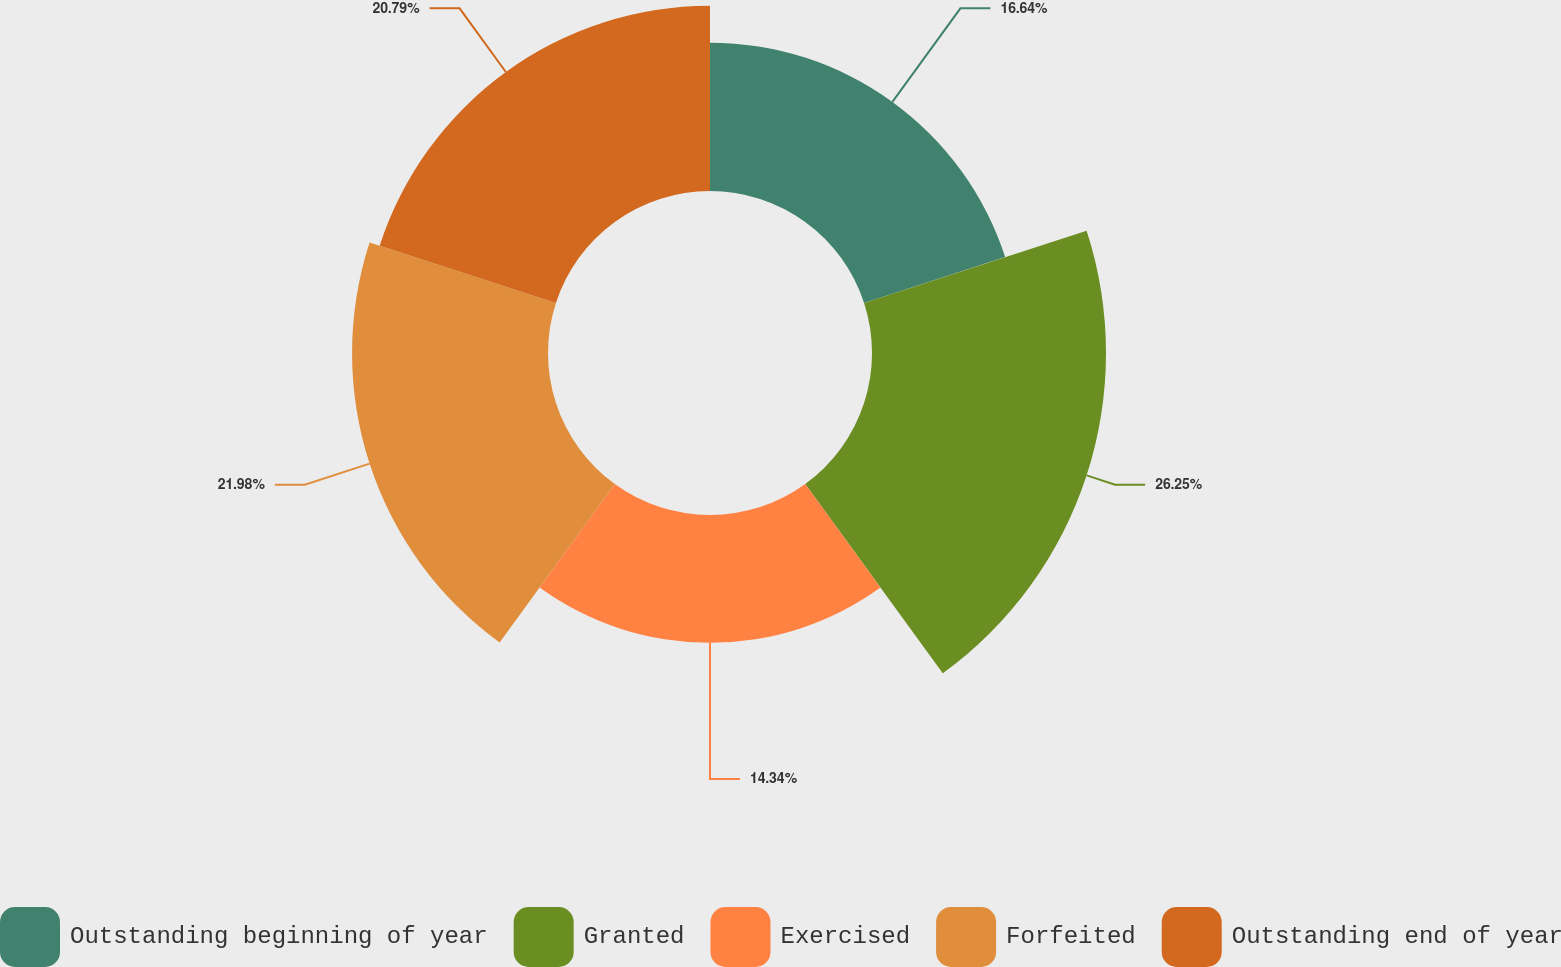Convert chart. <chart><loc_0><loc_0><loc_500><loc_500><pie_chart><fcel>Outstanding beginning of year<fcel>Granted<fcel>Exercised<fcel>Forfeited<fcel>Outstanding end of year<nl><fcel>16.64%<fcel>26.25%<fcel>14.34%<fcel>21.98%<fcel>20.79%<nl></chart> 